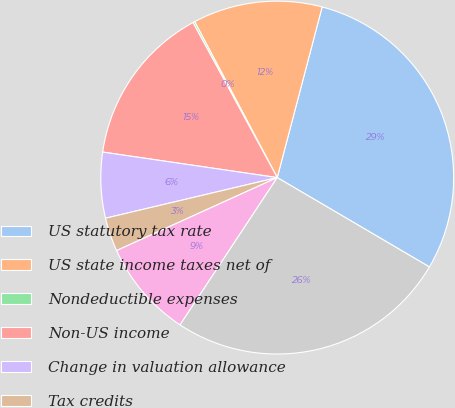Convert chart. <chart><loc_0><loc_0><loc_500><loc_500><pie_chart><fcel>US statutory tax rate<fcel>US state income taxes net of<fcel>Nondeductible expenses<fcel>Non-US income<fcel>Change in valuation allowance<fcel>Tax credits<fcel>Other net<fcel>Effective rate<nl><fcel>29.36%<fcel>11.85%<fcel>0.17%<fcel>14.77%<fcel>6.01%<fcel>3.09%<fcel>8.93%<fcel>25.84%<nl></chart> 